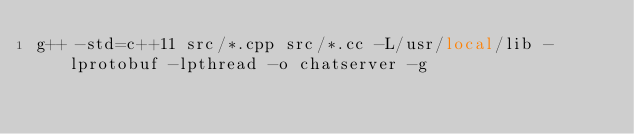Convert code to text. <code><loc_0><loc_0><loc_500><loc_500><_Bash_>g++ -std=c++11 src/*.cpp src/*.cc -L/usr/local/lib -lprotobuf -lpthread -o chatserver -g
</code> 